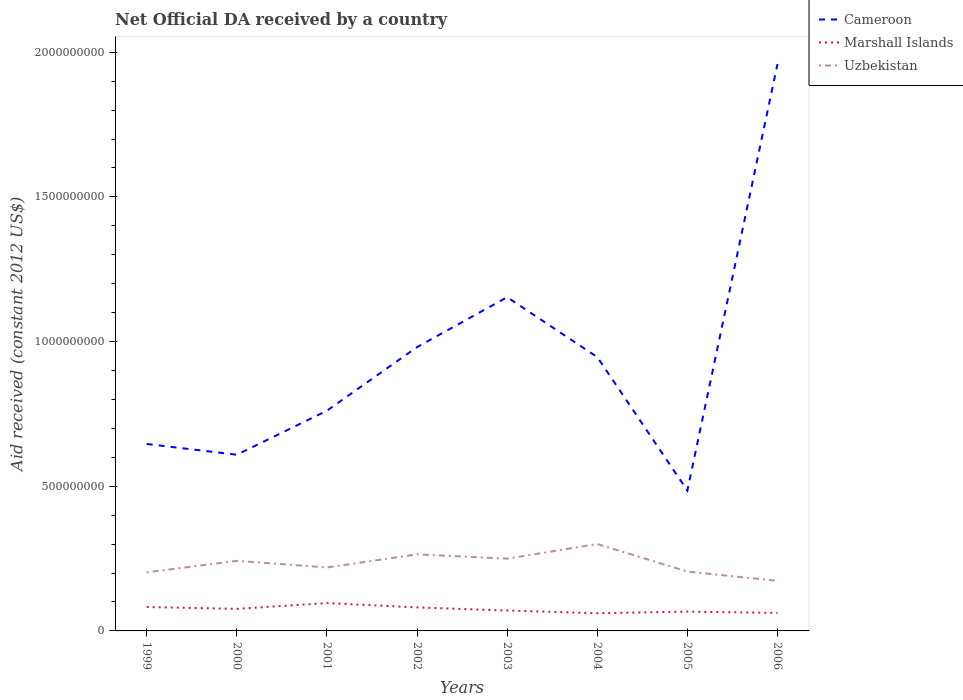How many different coloured lines are there?
Your answer should be very brief. 3. Does the line corresponding to Cameroon intersect with the line corresponding to Uzbekistan?
Your response must be concise. No. Across all years, what is the maximum net official development assistance aid received in Marshall Islands?
Make the answer very short. 6.12e+07. What is the total net official development assistance aid received in Uzbekistan in the graph?
Ensure brevity in your answer.  -3.97e+07. What is the difference between the highest and the second highest net official development assistance aid received in Uzbekistan?
Offer a terse response. 1.27e+08. What is the difference between the highest and the lowest net official development assistance aid received in Marshall Islands?
Keep it short and to the point. 4. How many years are there in the graph?
Offer a very short reply. 8. Where does the legend appear in the graph?
Offer a very short reply. Top right. How are the legend labels stacked?
Provide a succinct answer. Vertical. What is the title of the graph?
Make the answer very short. Net Official DA received by a country. What is the label or title of the X-axis?
Provide a short and direct response. Years. What is the label or title of the Y-axis?
Provide a succinct answer. Aid received (constant 2012 US$). What is the Aid received (constant 2012 US$) in Cameroon in 1999?
Offer a very short reply. 6.46e+08. What is the Aid received (constant 2012 US$) of Marshall Islands in 1999?
Offer a very short reply. 8.26e+07. What is the Aid received (constant 2012 US$) in Uzbekistan in 1999?
Offer a terse response. 2.02e+08. What is the Aid received (constant 2012 US$) of Cameroon in 2000?
Keep it short and to the point. 6.09e+08. What is the Aid received (constant 2012 US$) in Marshall Islands in 2000?
Ensure brevity in your answer.  7.62e+07. What is the Aid received (constant 2012 US$) of Uzbekistan in 2000?
Offer a terse response. 2.42e+08. What is the Aid received (constant 2012 US$) in Cameroon in 2001?
Offer a terse response. 7.61e+08. What is the Aid received (constant 2012 US$) in Marshall Islands in 2001?
Provide a short and direct response. 9.62e+07. What is the Aid received (constant 2012 US$) of Uzbekistan in 2001?
Offer a terse response. 2.19e+08. What is the Aid received (constant 2012 US$) in Cameroon in 2002?
Ensure brevity in your answer.  9.81e+08. What is the Aid received (constant 2012 US$) in Marshall Islands in 2002?
Keep it short and to the point. 8.13e+07. What is the Aid received (constant 2012 US$) in Uzbekistan in 2002?
Provide a short and direct response. 2.65e+08. What is the Aid received (constant 2012 US$) in Cameroon in 2003?
Provide a short and direct response. 1.15e+09. What is the Aid received (constant 2012 US$) of Marshall Islands in 2003?
Offer a terse response. 7.05e+07. What is the Aid received (constant 2012 US$) in Uzbekistan in 2003?
Offer a terse response. 2.50e+08. What is the Aid received (constant 2012 US$) in Cameroon in 2004?
Your answer should be compact. 9.46e+08. What is the Aid received (constant 2012 US$) in Marshall Islands in 2004?
Keep it short and to the point. 6.12e+07. What is the Aid received (constant 2012 US$) in Uzbekistan in 2004?
Your response must be concise. 3.00e+08. What is the Aid received (constant 2012 US$) in Cameroon in 2005?
Give a very brief answer. 4.85e+08. What is the Aid received (constant 2012 US$) in Marshall Islands in 2005?
Give a very brief answer. 6.67e+07. What is the Aid received (constant 2012 US$) of Uzbekistan in 2005?
Provide a succinct answer. 2.05e+08. What is the Aid received (constant 2012 US$) in Cameroon in 2006?
Keep it short and to the point. 1.96e+09. What is the Aid received (constant 2012 US$) in Marshall Islands in 2006?
Your response must be concise. 6.22e+07. What is the Aid received (constant 2012 US$) of Uzbekistan in 2006?
Provide a succinct answer. 1.73e+08. Across all years, what is the maximum Aid received (constant 2012 US$) of Cameroon?
Make the answer very short. 1.96e+09. Across all years, what is the maximum Aid received (constant 2012 US$) in Marshall Islands?
Your answer should be very brief. 9.62e+07. Across all years, what is the maximum Aid received (constant 2012 US$) in Uzbekistan?
Your response must be concise. 3.00e+08. Across all years, what is the minimum Aid received (constant 2012 US$) in Cameroon?
Offer a terse response. 4.85e+08. Across all years, what is the minimum Aid received (constant 2012 US$) in Marshall Islands?
Give a very brief answer. 6.12e+07. Across all years, what is the minimum Aid received (constant 2012 US$) in Uzbekistan?
Make the answer very short. 1.73e+08. What is the total Aid received (constant 2012 US$) of Cameroon in the graph?
Make the answer very short. 7.54e+09. What is the total Aid received (constant 2012 US$) in Marshall Islands in the graph?
Ensure brevity in your answer.  5.97e+08. What is the total Aid received (constant 2012 US$) of Uzbekistan in the graph?
Give a very brief answer. 1.86e+09. What is the difference between the Aid received (constant 2012 US$) in Cameroon in 1999 and that in 2000?
Provide a short and direct response. 3.72e+07. What is the difference between the Aid received (constant 2012 US$) in Marshall Islands in 1999 and that in 2000?
Your answer should be very brief. 6.41e+06. What is the difference between the Aid received (constant 2012 US$) in Uzbekistan in 1999 and that in 2000?
Provide a short and direct response. -3.97e+07. What is the difference between the Aid received (constant 2012 US$) in Cameroon in 1999 and that in 2001?
Offer a terse response. -1.15e+08. What is the difference between the Aid received (constant 2012 US$) in Marshall Islands in 1999 and that in 2001?
Your answer should be compact. -1.36e+07. What is the difference between the Aid received (constant 2012 US$) in Uzbekistan in 1999 and that in 2001?
Offer a terse response. -1.68e+07. What is the difference between the Aid received (constant 2012 US$) of Cameroon in 1999 and that in 2002?
Your response must be concise. -3.35e+08. What is the difference between the Aid received (constant 2012 US$) of Marshall Islands in 1999 and that in 2002?
Your answer should be compact. 1.34e+06. What is the difference between the Aid received (constant 2012 US$) of Uzbekistan in 1999 and that in 2002?
Make the answer very short. -6.22e+07. What is the difference between the Aid received (constant 2012 US$) of Cameroon in 1999 and that in 2003?
Offer a very short reply. -5.07e+08. What is the difference between the Aid received (constant 2012 US$) of Marshall Islands in 1999 and that in 2003?
Ensure brevity in your answer.  1.22e+07. What is the difference between the Aid received (constant 2012 US$) in Uzbekistan in 1999 and that in 2003?
Ensure brevity in your answer.  -4.73e+07. What is the difference between the Aid received (constant 2012 US$) of Cameroon in 1999 and that in 2004?
Offer a very short reply. -3.00e+08. What is the difference between the Aid received (constant 2012 US$) of Marshall Islands in 1999 and that in 2004?
Offer a very short reply. 2.14e+07. What is the difference between the Aid received (constant 2012 US$) in Uzbekistan in 1999 and that in 2004?
Give a very brief answer. -9.79e+07. What is the difference between the Aid received (constant 2012 US$) in Cameroon in 1999 and that in 2005?
Make the answer very short. 1.61e+08. What is the difference between the Aid received (constant 2012 US$) in Marshall Islands in 1999 and that in 2005?
Provide a succinct answer. 1.59e+07. What is the difference between the Aid received (constant 2012 US$) in Uzbekistan in 1999 and that in 2005?
Your response must be concise. -2.69e+06. What is the difference between the Aid received (constant 2012 US$) in Cameroon in 1999 and that in 2006?
Keep it short and to the point. -1.31e+09. What is the difference between the Aid received (constant 2012 US$) of Marshall Islands in 1999 and that in 2006?
Your answer should be very brief. 2.04e+07. What is the difference between the Aid received (constant 2012 US$) in Uzbekistan in 1999 and that in 2006?
Your answer should be compact. 2.93e+07. What is the difference between the Aid received (constant 2012 US$) in Cameroon in 2000 and that in 2001?
Ensure brevity in your answer.  -1.52e+08. What is the difference between the Aid received (constant 2012 US$) of Marshall Islands in 2000 and that in 2001?
Offer a very short reply. -2.00e+07. What is the difference between the Aid received (constant 2012 US$) of Uzbekistan in 2000 and that in 2001?
Ensure brevity in your answer.  2.29e+07. What is the difference between the Aid received (constant 2012 US$) in Cameroon in 2000 and that in 2002?
Offer a terse response. -3.72e+08. What is the difference between the Aid received (constant 2012 US$) of Marshall Islands in 2000 and that in 2002?
Your answer should be compact. -5.07e+06. What is the difference between the Aid received (constant 2012 US$) in Uzbekistan in 2000 and that in 2002?
Your response must be concise. -2.25e+07. What is the difference between the Aid received (constant 2012 US$) of Cameroon in 2000 and that in 2003?
Provide a short and direct response. -5.44e+08. What is the difference between the Aid received (constant 2012 US$) in Marshall Islands in 2000 and that in 2003?
Your response must be concise. 5.76e+06. What is the difference between the Aid received (constant 2012 US$) in Uzbekistan in 2000 and that in 2003?
Keep it short and to the point. -7.60e+06. What is the difference between the Aid received (constant 2012 US$) in Cameroon in 2000 and that in 2004?
Give a very brief answer. -3.37e+08. What is the difference between the Aid received (constant 2012 US$) of Marshall Islands in 2000 and that in 2004?
Ensure brevity in your answer.  1.50e+07. What is the difference between the Aid received (constant 2012 US$) in Uzbekistan in 2000 and that in 2004?
Keep it short and to the point. -5.82e+07. What is the difference between the Aid received (constant 2012 US$) in Cameroon in 2000 and that in 2005?
Make the answer very short. 1.24e+08. What is the difference between the Aid received (constant 2012 US$) in Marshall Islands in 2000 and that in 2005?
Offer a very short reply. 9.53e+06. What is the difference between the Aid received (constant 2012 US$) in Uzbekistan in 2000 and that in 2005?
Ensure brevity in your answer.  3.70e+07. What is the difference between the Aid received (constant 2012 US$) in Cameroon in 2000 and that in 2006?
Your answer should be compact. -1.35e+09. What is the difference between the Aid received (constant 2012 US$) in Marshall Islands in 2000 and that in 2006?
Your answer should be compact. 1.40e+07. What is the difference between the Aid received (constant 2012 US$) of Uzbekistan in 2000 and that in 2006?
Your answer should be compact. 6.90e+07. What is the difference between the Aid received (constant 2012 US$) in Cameroon in 2001 and that in 2002?
Keep it short and to the point. -2.20e+08. What is the difference between the Aid received (constant 2012 US$) in Marshall Islands in 2001 and that in 2002?
Offer a very short reply. 1.50e+07. What is the difference between the Aid received (constant 2012 US$) of Uzbekistan in 2001 and that in 2002?
Your response must be concise. -4.54e+07. What is the difference between the Aid received (constant 2012 US$) of Cameroon in 2001 and that in 2003?
Give a very brief answer. -3.92e+08. What is the difference between the Aid received (constant 2012 US$) of Marshall Islands in 2001 and that in 2003?
Offer a terse response. 2.58e+07. What is the difference between the Aid received (constant 2012 US$) of Uzbekistan in 2001 and that in 2003?
Your answer should be very brief. -3.05e+07. What is the difference between the Aid received (constant 2012 US$) of Cameroon in 2001 and that in 2004?
Give a very brief answer. -1.85e+08. What is the difference between the Aid received (constant 2012 US$) of Marshall Islands in 2001 and that in 2004?
Make the answer very short. 3.51e+07. What is the difference between the Aid received (constant 2012 US$) of Uzbekistan in 2001 and that in 2004?
Offer a terse response. -8.10e+07. What is the difference between the Aid received (constant 2012 US$) in Cameroon in 2001 and that in 2005?
Offer a very short reply. 2.76e+08. What is the difference between the Aid received (constant 2012 US$) of Marshall Islands in 2001 and that in 2005?
Offer a terse response. 2.96e+07. What is the difference between the Aid received (constant 2012 US$) of Uzbekistan in 2001 and that in 2005?
Ensure brevity in your answer.  1.42e+07. What is the difference between the Aid received (constant 2012 US$) of Cameroon in 2001 and that in 2006?
Your answer should be very brief. -1.20e+09. What is the difference between the Aid received (constant 2012 US$) in Marshall Islands in 2001 and that in 2006?
Provide a short and direct response. 3.41e+07. What is the difference between the Aid received (constant 2012 US$) of Uzbekistan in 2001 and that in 2006?
Your response must be concise. 4.61e+07. What is the difference between the Aid received (constant 2012 US$) of Cameroon in 2002 and that in 2003?
Your answer should be compact. -1.73e+08. What is the difference between the Aid received (constant 2012 US$) of Marshall Islands in 2002 and that in 2003?
Offer a very short reply. 1.08e+07. What is the difference between the Aid received (constant 2012 US$) in Uzbekistan in 2002 and that in 2003?
Give a very brief answer. 1.49e+07. What is the difference between the Aid received (constant 2012 US$) in Cameroon in 2002 and that in 2004?
Your response must be concise. 3.44e+07. What is the difference between the Aid received (constant 2012 US$) in Marshall Islands in 2002 and that in 2004?
Your answer should be very brief. 2.01e+07. What is the difference between the Aid received (constant 2012 US$) in Uzbekistan in 2002 and that in 2004?
Your response must be concise. -3.57e+07. What is the difference between the Aid received (constant 2012 US$) in Cameroon in 2002 and that in 2005?
Offer a very short reply. 4.96e+08. What is the difference between the Aid received (constant 2012 US$) of Marshall Islands in 2002 and that in 2005?
Make the answer very short. 1.46e+07. What is the difference between the Aid received (constant 2012 US$) in Uzbekistan in 2002 and that in 2005?
Your answer should be very brief. 5.95e+07. What is the difference between the Aid received (constant 2012 US$) of Cameroon in 2002 and that in 2006?
Your answer should be very brief. -9.78e+08. What is the difference between the Aid received (constant 2012 US$) of Marshall Islands in 2002 and that in 2006?
Give a very brief answer. 1.91e+07. What is the difference between the Aid received (constant 2012 US$) of Uzbekistan in 2002 and that in 2006?
Give a very brief answer. 9.15e+07. What is the difference between the Aid received (constant 2012 US$) in Cameroon in 2003 and that in 2004?
Keep it short and to the point. 2.07e+08. What is the difference between the Aid received (constant 2012 US$) of Marshall Islands in 2003 and that in 2004?
Make the answer very short. 9.27e+06. What is the difference between the Aid received (constant 2012 US$) in Uzbekistan in 2003 and that in 2004?
Provide a short and direct response. -5.06e+07. What is the difference between the Aid received (constant 2012 US$) of Cameroon in 2003 and that in 2005?
Keep it short and to the point. 6.68e+08. What is the difference between the Aid received (constant 2012 US$) in Marshall Islands in 2003 and that in 2005?
Make the answer very short. 3.77e+06. What is the difference between the Aid received (constant 2012 US$) in Uzbekistan in 2003 and that in 2005?
Your answer should be compact. 4.46e+07. What is the difference between the Aid received (constant 2012 US$) in Cameroon in 2003 and that in 2006?
Give a very brief answer. -8.06e+08. What is the difference between the Aid received (constant 2012 US$) in Marshall Islands in 2003 and that in 2006?
Your answer should be very brief. 8.28e+06. What is the difference between the Aid received (constant 2012 US$) of Uzbekistan in 2003 and that in 2006?
Provide a short and direct response. 7.66e+07. What is the difference between the Aid received (constant 2012 US$) of Cameroon in 2004 and that in 2005?
Your answer should be very brief. 4.61e+08. What is the difference between the Aid received (constant 2012 US$) of Marshall Islands in 2004 and that in 2005?
Make the answer very short. -5.50e+06. What is the difference between the Aid received (constant 2012 US$) of Uzbekistan in 2004 and that in 2005?
Give a very brief answer. 9.52e+07. What is the difference between the Aid received (constant 2012 US$) of Cameroon in 2004 and that in 2006?
Offer a very short reply. -1.01e+09. What is the difference between the Aid received (constant 2012 US$) of Marshall Islands in 2004 and that in 2006?
Make the answer very short. -9.90e+05. What is the difference between the Aid received (constant 2012 US$) in Uzbekistan in 2004 and that in 2006?
Your answer should be compact. 1.27e+08. What is the difference between the Aid received (constant 2012 US$) of Cameroon in 2005 and that in 2006?
Your answer should be very brief. -1.47e+09. What is the difference between the Aid received (constant 2012 US$) in Marshall Islands in 2005 and that in 2006?
Your response must be concise. 4.51e+06. What is the difference between the Aid received (constant 2012 US$) of Uzbekistan in 2005 and that in 2006?
Keep it short and to the point. 3.20e+07. What is the difference between the Aid received (constant 2012 US$) of Cameroon in 1999 and the Aid received (constant 2012 US$) of Marshall Islands in 2000?
Provide a short and direct response. 5.70e+08. What is the difference between the Aid received (constant 2012 US$) of Cameroon in 1999 and the Aid received (constant 2012 US$) of Uzbekistan in 2000?
Your answer should be very brief. 4.04e+08. What is the difference between the Aid received (constant 2012 US$) of Marshall Islands in 1999 and the Aid received (constant 2012 US$) of Uzbekistan in 2000?
Give a very brief answer. -1.59e+08. What is the difference between the Aid received (constant 2012 US$) of Cameroon in 1999 and the Aid received (constant 2012 US$) of Marshall Islands in 2001?
Your response must be concise. 5.50e+08. What is the difference between the Aid received (constant 2012 US$) in Cameroon in 1999 and the Aid received (constant 2012 US$) in Uzbekistan in 2001?
Offer a terse response. 4.27e+08. What is the difference between the Aid received (constant 2012 US$) in Marshall Islands in 1999 and the Aid received (constant 2012 US$) in Uzbekistan in 2001?
Give a very brief answer. -1.37e+08. What is the difference between the Aid received (constant 2012 US$) in Cameroon in 1999 and the Aid received (constant 2012 US$) in Marshall Islands in 2002?
Provide a succinct answer. 5.65e+08. What is the difference between the Aid received (constant 2012 US$) in Cameroon in 1999 and the Aid received (constant 2012 US$) in Uzbekistan in 2002?
Your answer should be very brief. 3.81e+08. What is the difference between the Aid received (constant 2012 US$) of Marshall Islands in 1999 and the Aid received (constant 2012 US$) of Uzbekistan in 2002?
Provide a short and direct response. -1.82e+08. What is the difference between the Aid received (constant 2012 US$) in Cameroon in 1999 and the Aid received (constant 2012 US$) in Marshall Islands in 2003?
Offer a very short reply. 5.76e+08. What is the difference between the Aid received (constant 2012 US$) of Cameroon in 1999 and the Aid received (constant 2012 US$) of Uzbekistan in 2003?
Offer a terse response. 3.96e+08. What is the difference between the Aid received (constant 2012 US$) in Marshall Islands in 1999 and the Aid received (constant 2012 US$) in Uzbekistan in 2003?
Your answer should be compact. -1.67e+08. What is the difference between the Aid received (constant 2012 US$) in Cameroon in 1999 and the Aid received (constant 2012 US$) in Marshall Islands in 2004?
Provide a short and direct response. 5.85e+08. What is the difference between the Aid received (constant 2012 US$) in Cameroon in 1999 and the Aid received (constant 2012 US$) in Uzbekistan in 2004?
Ensure brevity in your answer.  3.46e+08. What is the difference between the Aid received (constant 2012 US$) of Marshall Islands in 1999 and the Aid received (constant 2012 US$) of Uzbekistan in 2004?
Offer a very short reply. -2.18e+08. What is the difference between the Aid received (constant 2012 US$) of Cameroon in 1999 and the Aid received (constant 2012 US$) of Marshall Islands in 2005?
Provide a short and direct response. 5.79e+08. What is the difference between the Aid received (constant 2012 US$) in Cameroon in 1999 and the Aid received (constant 2012 US$) in Uzbekistan in 2005?
Offer a very short reply. 4.41e+08. What is the difference between the Aid received (constant 2012 US$) of Marshall Islands in 1999 and the Aid received (constant 2012 US$) of Uzbekistan in 2005?
Your answer should be compact. -1.22e+08. What is the difference between the Aid received (constant 2012 US$) in Cameroon in 1999 and the Aid received (constant 2012 US$) in Marshall Islands in 2006?
Your answer should be very brief. 5.84e+08. What is the difference between the Aid received (constant 2012 US$) of Cameroon in 1999 and the Aid received (constant 2012 US$) of Uzbekistan in 2006?
Your answer should be compact. 4.73e+08. What is the difference between the Aid received (constant 2012 US$) in Marshall Islands in 1999 and the Aid received (constant 2012 US$) in Uzbekistan in 2006?
Offer a terse response. -9.05e+07. What is the difference between the Aid received (constant 2012 US$) of Cameroon in 2000 and the Aid received (constant 2012 US$) of Marshall Islands in 2001?
Your answer should be compact. 5.13e+08. What is the difference between the Aid received (constant 2012 US$) in Cameroon in 2000 and the Aid received (constant 2012 US$) in Uzbekistan in 2001?
Make the answer very short. 3.90e+08. What is the difference between the Aid received (constant 2012 US$) of Marshall Islands in 2000 and the Aid received (constant 2012 US$) of Uzbekistan in 2001?
Offer a terse response. -1.43e+08. What is the difference between the Aid received (constant 2012 US$) of Cameroon in 2000 and the Aid received (constant 2012 US$) of Marshall Islands in 2002?
Make the answer very short. 5.28e+08. What is the difference between the Aid received (constant 2012 US$) of Cameroon in 2000 and the Aid received (constant 2012 US$) of Uzbekistan in 2002?
Give a very brief answer. 3.44e+08. What is the difference between the Aid received (constant 2012 US$) of Marshall Islands in 2000 and the Aid received (constant 2012 US$) of Uzbekistan in 2002?
Your answer should be very brief. -1.88e+08. What is the difference between the Aid received (constant 2012 US$) in Cameroon in 2000 and the Aid received (constant 2012 US$) in Marshall Islands in 2003?
Offer a terse response. 5.38e+08. What is the difference between the Aid received (constant 2012 US$) of Cameroon in 2000 and the Aid received (constant 2012 US$) of Uzbekistan in 2003?
Make the answer very short. 3.59e+08. What is the difference between the Aid received (constant 2012 US$) of Marshall Islands in 2000 and the Aid received (constant 2012 US$) of Uzbekistan in 2003?
Make the answer very short. -1.74e+08. What is the difference between the Aid received (constant 2012 US$) of Cameroon in 2000 and the Aid received (constant 2012 US$) of Marshall Islands in 2004?
Ensure brevity in your answer.  5.48e+08. What is the difference between the Aid received (constant 2012 US$) of Cameroon in 2000 and the Aid received (constant 2012 US$) of Uzbekistan in 2004?
Give a very brief answer. 3.09e+08. What is the difference between the Aid received (constant 2012 US$) of Marshall Islands in 2000 and the Aid received (constant 2012 US$) of Uzbekistan in 2004?
Offer a very short reply. -2.24e+08. What is the difference between the Aid received (constant 2012 US$) in Cameroon in 2000 and the Aid received (constant 2012 US$) in Marshall Islands in 2005?
Make the answer very short. 5.42e+08. What is the difference between the Aid received (constant 2012 US$) of Cameroon in 2000 and the Aid received (constant 2012 US$) of Uzbekistan in 2005?
Ensure brevity in your answer.  4.04e+08. What is the difference between the Aid received (constant 2012 US$) in Marshall Islands in 2000 and the Aid received (constant 2012 US$) in Uzbekistan in 2005?
Your response must be concise. -1.29e+08. What is the difference between the Aid received (constant 2012 US$) of Cameroon in 2000 and the Aid received (constant 2012 US$) of Marshall Islands in 2006?
Your answer should be very brief. 5.47e+08. What is the difference between the Aid received (constant 2012 US$) in Cameroon in 2000 and the Aid received (constant 2012 US$) in Uzbekistan in 2006?
Your answer should be very brief. 4.36e+08. What is the difference between the Aid received (constant 2012 US$) of Marshall Islands in 2000 and the Aid received (constant 2012 US$) of Uzbekistan in 2006?
Your answer should be compact. -9.69e+07. What is the difference between the Aid received (constant 2012 US$) in Cameroon in 2001 and the Aid received (constant 2012 US$) in Marshall Islands in 2002?
Give a very brief answer. 6.80e+08. What is the difference between the Aid received (constant 2012 US$) in Cameroon in 2001 and the Aid received (constant 2012 US$) in Uzbekistan in 2002?
Your response must be concise. 4.96e+08. What is the difference between the Aid received (constant 2012 US$) in Marshall Islands in 2001 and the Aid received (constant 2012 US$) in Uzbekistan in 2002?
Provide a succinct answer. -1.68e+08. What is the difference between the Aid received (constant 2012 US$) in Cameroon in 2001 and the Aid received (constant 2012 US$) in Marshall Islands in 2003?
Make the answer very short. 6.91e+08. What is the difference between the Aid received (constant 2012 US$) of Cameroon in 2001 and the Aid received (constant 2012 US$) of Uzbekistan in 2003?
Give a very brief answer. 5.11e+08. What is the difference between the Aid received (constant 2012 US$) in Marshall Islands in 2001 and the Aid received (constant 2012 US$) in Uzbekistan in 2003?
Make the answer very short. -1.53e+08. What is the difference between the Aid received (constant 2012 US$) in Cameroon in 2001 and the Aid received (constant 2012 US$) in Marshall Islands in 2004?
Your response must be concise. 7.00e+08. What is the difference between the Aid received (constant 2012 US$) in Cameroon in 2001 and the Aid received (constant 2012 US$) in Uzbekistan in 2004?
Offer a terse response. 4.61e+08. What is the difference between the Aid received (constant 2012 US$) of Marshall Islands in 2001 and the Aid received (constant 2012 US$) of Uzbekistan in 2004?
Your answer should be very brief. -2.04e+08. What is the difference between the Aid received (constant 2012 US$) in Cameroon in 2001 and the Aid received (constant 2012 US$) in Marshall Islands in 2005?
Offer a terse response. 6.94e+08. What is the difference between the Aid received (constant 2012 US$) of Cameroon in 2001 and the Aid received (constant 2012 US$) of Uzbekistan in 2005?
Offer a terse response. 5.56e+08. What is the difference between the Aid received (constant 2012 US$) in Marshall Islands in 2001 and the Aid received (constant 2012 US$) in Uzbekistan in 2005?
Ensure brevity in your answer.  -1.09e+08. What is the difference between the Aid received (constant 2012 US$) of Cameroon in 2001 and the Aid received (constant 2012 US$) of Marshall Islands in 2006?
Provide a succinct answer. 6.99e+08. What is the difference between the Aid received (constant 2012 US$) in Cameroon in 2001 and the Aid received (constant 2012 US$) in Uzbekistan in 2006?
Ensure brevity in your answer.  5.88e+08. What is the difference between the Aid received (constant 2012 US$) in Marshall Islands in 2001 and the Aid received (constant 2012 US$) in Uzbekistan in 2006?
Make the answer very short. -7.69e+07. What is the difference between the Aid received (constant 2012 US$) in Cameroon in 2002 and the Aid received (constant 2012 US$) in Marshall Islands in 2003?
Provide a short and direct response. 9.10e+08. What is the difference between the Aid received (constant 2012 US$) in Cameroon in 2002 and the Aid received (constant 2012 US$) in Uzbekistan in 2003?
Offer a very short reply. 7.31e+08. What is the difference between the Aid received (constant 2012 US$) of Marshall Islands in 2002 and the Aid received (constant 2012 US$) of Uzbekistan in 2003?
Your answer should be very brief. -1.68e+08. What is the difference between the Aid received (constant 2012 US$) in Cameroon in 2002 and the Aid received (constant 2012 US$) in Marshall Islands in 2004?
Offer a terse response. 9.20e+08. What is the difference between the Aid received (constant 2012 US$) in Cameroon in 2002 and the Aid received (constant 2012 US$) in Uzbekistan in 2004?
Your answer should be very brief. 6.80e+08. What is the difference between the Aid received (constant 2012 US$) of Marshall Islands in 2002 and the Aid received (constant 2012 US$) of Uzbekistan in 2004?
Your answer should be very brief. -2.19e+08. What is the difference between the Aid received (constant 2012 US$) of Cameroon in 2002 and the Aid received (constant 2012 US$) of Marshall Islands in 2005?
Provide a succinct answer. 9.14e+08. What is the difference between the Aid received (constant 2012 US$) of Cameroon in 2002 and the Aid received (constant 2012 US$) of Uzbekistan in 2005?
Your response must be concise. 7.76e+08. What is the difference between the Aid received (constant 2012 US$) of Marshall Islands in 2002 and the Aid received (constant 2012 US$) of Uzbekistan in 2005?
Provide a succinct answer. -1.24e+08. What is the difference between the Aid received (constant 2012 US$) in Cameroon in 2002 and the Aid received (constant 2012 US$) in Marshall Islands in 2006?
Give a very brief answer. 9.19e+08. What is the difference between the Aid received (constant 2012 US$) of Cameroon in 2002 and the Aid received (constant 2012 US$) of Uzbekistan in 2006?
Provide a succinct answer. 8.08e+08. What is the difference between the Aid received (constant 2012 US$) in Marshall Islands in 2002 and the Aid received (constant 2012 US$) in Uzbekistan in 2006?
Provide a succinct answer. -9.18e+07. What is the difference between the Aid received (constant 2012 US$) in Cameroon in 2003 and the Aid received (constant 2012 US$) in Marshall Islands in 2004?
Provide a short and direct response. 1.09e+09. What is the difference between the Aid received (constant 2012 US$) in Cameroon in 2003 and the Aid received (constant 2012 US$) in Uzbekistan in 2004?
Ensure brevity in your answer.  8.53e+08. What is the difference between the Aid received (constant 2012 US$) of Marshall Islands in 2003 and the Aid received (constant 2012 US$) of Uzbekistan in 2004?
Your answer should be compact. -2.30e+08. What is the difference between the Aid received (constant 2012 US$) of Cameroon in 2003 and the Aid received (constant 2012 US$) of Marshall Islands in 2005?
Offer a very short reply. 1.09e+09. What is the difference between the Aid received (constant 2012 US$) of Cameroon in 2003 and the Aid received (constant 2012 US$) of Uzbekistan in 2005?
Ensure brevity in your answer.  9.48e+08. What is the difference between the Aid received (constant 2012 US$) of Marshall Islands in 2003 and the Aid received (constant 2012 US$) of Uzbekistan in 2005?
Ensure brevity in your answer.  -1.35e+08. What is the difference between the Aid received (constant 2012 US$) in Cameroon in 2003 and the Aid received (constant 2012 US$) in Marshall Islands in 2006?
Ensure brevity in your answer.  1.09e+09. What is the difference between the Aid received (constant 2012 US$) in Cameroon in 2003 and the Aid received (constant 2012 US$) in Uzbekistan in 2006?
Offer a very short reply. 9.80e+08. What is the difference between the Aid received (constant 2012 US$) in Marshall Islands in 2003 and the Aid received (constant 2012 US$) in Uzbekistan in 2006?
Provide a succinct answer. -1.03e+08. What is the difference between the Aid received (constant 2012 US$) of Cameroon in 2004 and the Aid received (constant 2012 US$) of Marshall Islands in 2005?
Ensure brevity in your answer.  8.80e+08. What is the difference between the Aid received (constant 2012 US$) in Cameroon in 2004 and the Aid received (constant 2012 US$) in Uzbekistan in 2005?
Keep it short and to the point. 7.41e+08. What is the difference between the Aid received (constant 2012 US$) of Marshall Islands in 2004 and the Aid received (constant 2012 US$) of Uzbekistan in 2005?
Offer a very short reply. -1.44e+08. What is the difference between the Aid received (constant 2012 US$) in Cameroon in 2004 and the Aid received (constant 2012 US$) in Marshall Islands in 2006?
Provide a succinct answer. 8.84e+08. What is the difference between the Aid received (constant 2012 US$) of Cameroon in 2004 and the Aid received (constant 2012 US$) of Uzbekistan in 2006?
Offer a terse response. 7.73e+08. What is the difference between the Aid received (constant 2012 US$) in Marshall Islands in 2004 and the Aid received (constant 2012 US$) in Uzbekistan in 2006?
Provide a succinct answer. -1.12e+08. What is the difference between the Aid received (constant 2012 US$) of Cameroon in 2005 and the Aid received (constant 2012 US$) of Marshall Islands in 2006?
Provide a short and direct response. 4.23e+08. What is the difference between the Aid received (constant 2012 US$) in Cameroon in 2005 and the Aid received (constant 2012 US$) in Uzbekistan in 2006?
Keep it short and to the point. 3.12e+08. What is the difference between the Aid received (constant 2012 US$) in Marshall Islands in 2005 and the Aid received (constant 2012 US$) in Uzbekistan in 2006?
Your answer should be compact. -1.06e+08. What is the average Aid received (constant 2012 US$) of Cameroon per year?
Keep it short and to the point. 9.43e+08. What is the average Aid received (constant 2012 US$) of Marshall Islands per year?
Make the answer very short. 7.46e+07. What is the average Aid received (constant 2012 US$) of Uzbekistan per year?
Provide a succinct answer. 2.32e+08. In the year 1999, what is the difference between the Aid received (constant 2012 US$) in Cameroon and Aid received (constant 2012 US$) in Marshall Islands?
Ensure brevity in your answer.  5.63e+08. In the year 1999, what is the difference between the Aid received (constant 2012 US$) in Cameroon and Aid received (constant 2012 US$) in Uzbekistan?
Ensure brevity in your answer.  4.44e+08. In the year 1999, what is the difference between the Aid received (constant 2012 US$) of Marshall Islands and Aid received (constant 2012 US$) of Uzbekistan?
Offer a very short reply. -1.20e+08. In the year 2000, what is the difference between the Aid received (constant 2012 US$) in Cameroon and Aid received (constant 2012 US$) in Marshall Islands?
Ensure brevity in your answer.  5.33e+08. In the year 2000, what is the difference between the Aid received (constant 2012 US$) of Cameroon and Aid received (constant 2012 US$) of Uzbekistan?
Provide a succinct answer. 3.67e+08. In the year 2000, what is the difference between the Aid received (constant 2012 US$) in Marshall Islands and Aid received (constant 2012 US$) in Uzbekistan?
Keep it short and to the point. -1.66e+08. In the year 2001, what is the difference between the Aid received (constant 2012 US$) of Cameroon and Aid received (constant 2012 US$) of Marshall Islands?
Offer a terse response. 6.65e+08. In the year 2001, what is the difference between the Aid received (constant 2012 US$) of Cameroon and Aid received (constant 2012 US$) of Uzbekistan?
Keep it short and to the point. 5.42e+08. In the year 2001, what is the difference between the Aid received (constant 2012 US$) in Marshall Islands and Aid received (constant 2012 US$) in Uzbekistan?
Your answer should be compact. -1.23e+08. In the year 2002, what is the difference between the Aid received (constant 2012 US$) in Cameroon and Aid received (constant 2012 US$) in Marshall Islands?
Provide a succinct answer. 9.00e+08. In the year 2002, what is the difference between the Aid received (constant 2012 US$) in Cameroon and Aid received (constant 2012 US$) in Uzbekistan?
Your answer should be very brief. 7.16e+08. In the year 2002, what is the difference between the Aid received (constant 2012 US$) of Marshall Islands and Aid received (constant 2012 US$) of Uzbekistan?
Ensure brevity in your answer.  -1.83e+08. In the year 2003, what is the difference between the Aid received (constant 2012 US$) in Cameroon and Aid received (constant 2012 US$) in Marshall Islands?
Ensure brevity in your answer.  1.08e+09. In the year 2003, what is the difference between the Aid received (constant 2012 US$) of Cameroon and Aid received (constant 2012 US$) of Uzbekistan?
Provide a succinct answer. 9.04e+08. In the year 2003, what is the difference between the Aid received (constant 2012 US$) of Marshall Islands and Aid received (constant 2012 US$) of Uzbekistan?
Offer a very short reply. -1.79e+08. In the year 2004, what is the difference between the Aid received (constant 2012 US$) of Cameroon and Aid received (constant 2012 US$) of Marshall Islands?
Make the answer very short. 8.85e+08. In the year 2004, what is the difference between the Aid received (constant 2012 US$) of Cameroon and Aid received (constant 2012 US$) of Uzbekistan?
Make the answer very short. 6.46e+08. In the year 2004, what is the difference between the Aid received (constant 2012 US$) in Marshall Islands and Aid received (constant 2012 US$) in Uzbekistan?
Ensure brevity in your answer.  -2.39e+08. In the year 2005, what is the difference between the Aid received (constant 2012 US$) in Cameroon and Aid received (constant 2012 US$) in Marshall Islands?
Give a very brief answer. 4.19e+08. In the year 2005, what is the difference between the Aid received (constant 2012 US$) in Cameroon and Aid received (constant 2012 US$) in Uzbekistan?
Offer a very short reply. 2.80e+08. In the year 2005, what is the difference between the Aid received (constant 2012 US$) in Marshall Islands and Aid received (constant 2012 US$) in Uzbekistan?
Keep it short and to the point. -1.38e+08. In the year 2006, what is the difference between the Aid received (constant 2012 US$) in Cameroon and Aid received (constant 2012 US$) in Marshall Islands?
Give a very brief answer. 1.90e+09. In the year 2006, what is the difference between the Aid received (constant 2012 US$) of Cameroon and Aid received (constant 2012 US$) of Uzbekistan?
Offer a terse response. 1.79e+09. In the year 2006, what is the difference between the Aid received (constant 2012 US$) of Marshall Islands and Aid received (constant 2012 US$) of Uzbekistan?
Your response must be concise. -1.11e+08. What is the ratio of the Aid received (constant 2012 US$) in Cameroon in 1999 to that in 2000?
Provide a succinct answer. 1.06. What is the ratio of the Aid received (constant 2012 US$) of Marshall Islands in 1999 to that in 2000?
Your response must be concise. 1.08. What is the ratio of the Aid received (constant 2012 US$) of Uzbekistan in 1999 to that in 2000?
Your response must be concise. 0.84. What is the ratio of the Aid received (constant 2012 US$) in Cameroon in 1999 to that in 2001?
Make the answer very short. 0.85. What is the ratio of the Aid received (constant 2012 US$) in Marshall Islands in 1999 to that in 2001?
Provide a short and direct response. 0.86. What is the ratio of the Aid received (constant 2012 US$) of Uzbekistan in 1999 to that in 2001?
Make the answer very short. 0.92. What is the ratio of the Aid received (constant 2012 US$) of Cameroon in 1999 to that in 2002?
Keep it short and to the point. 0.66. What is the ratio of the Aid received (constant 2012 US$) in Marshall Islands in 1999 to that in 2002?
Ensure brevity in your answer.  1.02. What is the ratio of the Aid received (constant 2012 US$) of Uzbekistan in 1999 to that in 2002?
Your answer should be compact. 0.76. What is the ratio of the Aid received (constant 2012 US$) of Cameroon in 1999 to that in 2003?
Your answer should be compact. 0.56. What is the ratio of the Aid received (constant 2012 US$) in Marshall Islands in 1999 to that in 2003?
Give a very brief answer. 1.17. What is the ratio of the Aid received (constant 2012 US$) of Uzbekistan in 1999 to that in 2003?
Provide a short and direct response. 0.81. What is the ratio of the Aid received (constant 2012 US$) in Cameroon in 1999 to that in 2004?
Give a very brief answer. 0.68. What is the ratio of the Aid received (constant 2012 US$) of Marshall Islands in 1999 to that in 2004?
Give a very brief answer. 1.35. What is the ratio of the Aid received (constant 2012 US$) in Uzbekistan in 1999 to that in 2004?
Ensure brevity in your answer.  0.67. What is the ratio of the Aid received (constant 2012 US$) of Cameroon in 1999 to that in 2005?
Your answer should be compact. 1.33. What is the ratio of the Aid received (constant 2012 US$) in Marshall Islands in 1999 to that in 2005?
Make the answer very short. 1.24. What is the ratio of the Aid received (constant 2012 US$) of Uzbekistan in 1999 to that in 2005?
Keep it short and to the point. 0.99. What is the ratio of the Aid received (constant 2012 US$) in Cameroon in 1999 to that in 2006?
Your answer should be compact. 0.33. What is the ratio of the Aid received (constant 2012 US$) in Marshall Islands in 1999 to that in 2006?
Ensure brevity in your answer.  1.33. What is the ratio of the Aid received (constant 2012 US$) of Uzbekistan in 1999 to that in 2006?
Offer a very short reply. 1.17. What is the ratio of the Aid received (constant 2012 US$) of Marshall Islands in 2000 to that in 2001?
Your answer should be compact. 0.79. What is the ratio of the Aid received (constant 2012 US$) in Uzbekistan in 2000 to that in 2001?
Your answer should be compact. 1.1. What is the ratio of the Aid received (constant 2012 US$) in Cameroon in 2000 to that in 2002?
Keep it short and to the point. 0.62. What is the ratio of the Aid received (constant 2012 US$) of Marshall Islands in 2000 to that in 2002?
Your response must be concise. 0.94. What is the ratio of the Aid received (constant 2012 US$) of Uzbekistan in 2000 to that in 2002?
Your answer should be very brief. 0.91. What is the ratio of the Aid received (constant 2012 US$) in Cameroon in 2000 to that in 2003?
Keep it short and to the point. 0.53. What is the ratio of the Aid received (constant 2012 US$) in Marshall Islands in 2000 to that in 2003?
Provide a succinct answer. 1.08. What is the ratio of the Aid received (constant 2012 US$) in Uzbekistan in 2000 to that in 2003?
Provide a succinct answer. 0.97. What is the ratio of the Aid received (constant 2012 US$) of Cameroon in 2000 to that in 2004?
Your answer should be very brief. 0.64. What is the ratio of the Aid received (constant 2012 US$) of Marshall Islands in 2000 to that in 2004?
Your response must be concise. 1.25. What is the ratio of the Aid received (constant 2012 US$) of Uzbekistan in 2000 to that in 2004?
Provide a succinct answer. 0.81. What is the ratio of the Aid received (constant 2012 US$) in Cameroon in 2000 to that in 2005?
Ensure brevity in your answer.  1.25. What is the ratio of the Aid received (constant 2012 US$) in Marshall Islands in 2000 to that in 2005?
Provide a succinct answer. 1.14. What is the ratio of the Aid received (constant 2012 US$) in Uzbekistan in 2000 to that in 2005?
Keep it short and to the point. 1.18. What is the ratio of the Aid received (constant 2012 US$) of Cameroon in 2000 to that in 2006?
Offer a very short reply. 0.31. What is the ratio of the Aid received (constant 2012 US$) of Marshall Islands in 2000 to that in 2006?
Offer a very short reply. 1.23. What is the ratio of the Aid received (constant 2012 US$) of Uzbekistan in 2000 to that in 2006?
Make the answer very short. 1.4. What is the ratio of the Aid received (constant 2012 US$) of Cameroon in 2001 to that in 2002?
Your response must be concise. 0.78. What is the ratio of the Aid received (constant 2012 US$) of Marshall Islands in 2001 to that in 2002?
Provide a short and direct response. 1.18. What is the ratio of the Aid received (constant 2012 US$) of Uzbekistan in 2001 to that in 2002?
Offer a terse response. 0.83. What is the ratio of the Aid received (constant 2012 US$) in Cameroon in 2001 to that in 2003?
Give a very brief answer. 0.66. What is the ratio of the Aid received (constant 2012 US$) in Marshall Islands in 2001 to that in 2003?
Provide a succinct answer. 1.37. What is the ratio of the Aid received (constant 2012 US$) in Uzbekistan in 2001 to that in 2003?
Your answer should be compact. 0.88. What is the ratio of the Aid received (constant 2012 US$) in Cameroon in 2001 to that in 2004?
Make the answer very short. 0.8. What is the ratio of the Aid received (constant 2012 US$) in Marshall Islands in 2001 to that in 2004?
Provide a succinct answer. 1.57. What is the ratio of the Aid received (constant 2012 US$) of Uzbekistan in 2001 to that in 2004?
Provide a succinct answer. 0.73. What is the ratio of the Aid received (constant 2012 US$) in Cameroon in 2001 to that in 2005?
Your answer should be very brief. 1.57. What is the ratio of the Aid received (constant 2012 US$) in Marshall Islands in 2001 to that in 2005?
Give a very brief answer. 1.44. What is the ratio of the Aid received (constant 2012 US$) of Uzbekistan in 2001 to that in 2005?
Provide a succinct answer. 1.07. What is the ratio of the Aid received (constant 2012 US$) in Cameroon in 2001 to that in 2006?
Make the answer very short. 0.39. What is the ratio of the Aid received (constant 2012 US$) in Marshall Islands in 2001 to that in 2006?
Your answer should be compact. 1.55. What is the ratio of the Aid received (constant 2012 US$) in Uzbekistan in 2001 to that in 2006?
Offer a terse response. 1.27. What is the ratio of the Aid received (constant 2012 US$) of Cameroon in 2002 to that in 2003?
Ensure brevity in your answer.  0.85. What is the ratio of the Aid received (constant 2012 US$) in Marshall Islands in 2002 to that in 2003?
Your response must be concise. 1.15. What is the ratio of the Aid received (constant 2012 US$) in Uzbekistan in 2002 to that in 2003?
Your answer should be very brief. 1.06. What is the ratio of the Aid received (constant 2012 US$) of Cameroon in 2002 to that in 2004?
Your answer should be very brief. 1.04. What is the ratio of the Aid received (constant 2012 US$) of Marshall Islands in 2002 to that in 2004?
Offer a terse response. 1.33. What is the ratio of the Aid received (constant 2012 US$) of Uzbekistan in 2002 to that in 2004?
Make the answer very short. 0.88. What is the ratio of the Aid received (constant 2012 US$) in Cameroon in 2002 to that in 2005?
Your answer should be very brief. 2.02. What is the ratio of the Aid received (constant 2012 US$) in Marshall Islands in 2002 to that in 2005?
Provide a succinct answer. 1.22. What is the ratio of the Aid received (constant 2012 US$) in Uzbekistan in 2002 to that in 2005?
Ensure brevity in your answer.  1.29. What is the ratio of the Aid received (constant 2012 US$) in Cameroon in 2002 to that in 2006?
Keep it short and to the point. 0.5. What is the ratio of the Aid received (constant 2012 US$) in Marshall Islands in 2002 to that in 2006?
Ensure brevity in your answer.  1.31. What is the ratio of the Aid received (constant 2012 US$) in Uzbekistan in 2002 to that in 2006?
Ensure brevity in your answer.  1.53. What is the ratio of the Aid received (constant 2012 US$) in Cameroon in 2003 to that in 2004?
Give a very brief answer. 1.22. What is the ratio of the Aid received (constant 2012 US$) of Marshall Islands in 2003 to that in 2004?
Make the answer very short. 1.15. What is the ratio of the Aid received (constant 2012 US$) of Uzbekistan in 2003 to that in 2004?
Your answer should be compact. 0.83. What is the ratio of the Aid received (constant 2012 US$) of Cameroon in 2003 to that in 2005?
Keep it short and to the point. 2.38. What is the ratio of the Aid received (constant 2012 US$) in Marshall Islands in 2003 to that in 2005?
Your response must be concise. 1.06. What is the ratio of the Aid received (constant 2012 US$) of Uzbekistan in 2003 to that in 2005?
Ensure brevity in your answer.  1.22. What is the ratio of the Aid received (constant 2012 US$) of Cameroon in 2003 to that in 2006?
Your response must be concise. 0.59. What is the ratio of the Aid received (constant 2012 US$) of Marshall Islands in 2003 to that in 2006?
Provide a short and direct response. 1.13. What is the ratio of the Aid received (constant 2012 US$) in Uzbekistan in 2003 to that in 2006?
Make the answer very short. 1.44. What is the ratio of the Aid received (constant 2012 US$) in Cameroon in 2004 to that in 2005?
Your response must be concise. 1.95. What is the ratio of the Aid received (constant 2012 US$) in Marshall Islands in 2004 to that in 2005?
Ensure brevity in your answer.  0.92. What is the ratio of the Aid received (constant 2012 US$) of Uzbekistan in 2004 to that in 2005?
Provide a short and direct response. 1.46. What is the ratio of the Aid received (constant 2012 US$) of Cameroon in 2004 to that in 2006?
Your answer should be very brief. 0.48. What is the ratio of the Aid received (constant 2012 US$) in Marshall Islands in 2004 to that in 2006?
Provide a short and direct response. 0.98. What is the ratio of the Aid received (constant 2012 US$) of Uzbekistan in 2004 to that in 2006?
Keep it short and to the point. 1.73. What is the ratio of the Aid received (constant 2012 US$) in Cameroon in 2005 to that in 2006?
Your response must be concise. 0.25. What is the ratio of the Aid received (constant 2012 US$) of Marshall Islands in 2005 to that in 2006?
Your answer should be compact. 1.07. What is the ratio of the Aid received (constant 2012 US$) of Uzbekistan in 2005 to that in 2006?
Offer a terse response. 1.18. What is the difference between the highest and the second highest Aid received (constant 2012 US$) of Cameroon?
Provide a succinct answer. 8.06e+08. What is the difference between the highest and the second highest Aid received (constant 2012 US$) of Marshall Islands?
Keep it short and to the point. 1.36e+07. What is the difference between the highest and the second highest Aid received (constant 2012 US$) in Uzbekistan?
Provide a succinct answer. 3.57e+07. What is the difference between the highest and the lowest Aid received (constant 2012 US$) in Cameroon?
Your answer should be very brief. 1.47e+09. What is the difference between the highest and the lowest Aid received (constant 2012 US$) of Marshall Islands?
Make the answer very short. 3.51e+07. What is the difference between the highest and the lowest Aid received (constant 2012 US$) of Uzbekistan?
Your response must be concise. 1.27e+08. 